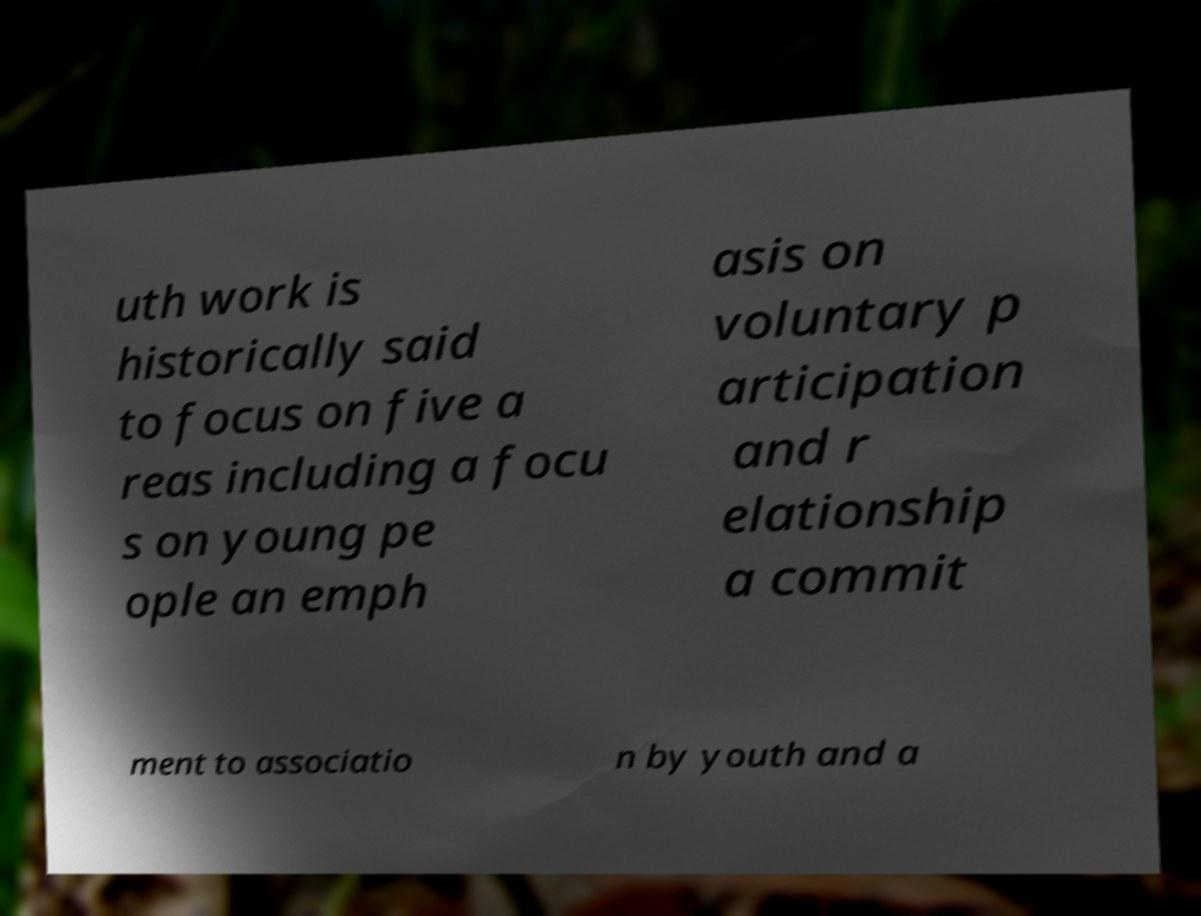Please read and relay the text visible in this image. What does it say? uth work is historically said to focus on five a reas including a focu s on young pe ople an emph asis on voluntary p articipation and r elationship a commit ment to associatio n by youth and a 